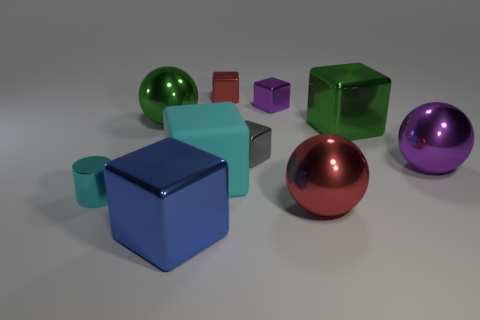Subtract all purple cubes. How many cubes are left? 5 Subtract all rubber cubes. How many cubes are left? 5 Subtract 2 blocks. How many blocks are left? 4 Subtract all brown blocks. Subtract all purple cylinders. How many blocks are left? 6 Subtract all cylinders. How many objects are left? 9 Add 4 blue things. How many blue things exist? 5 Subtract 0 cyan spheres. How many objects are left? 10 Subtract all tiny green rubber blocks. Subtract all big blue metallic objects. How many objects are left? 9 Add 9 large blue metal objects. How many large blue metal objects are left? 10 